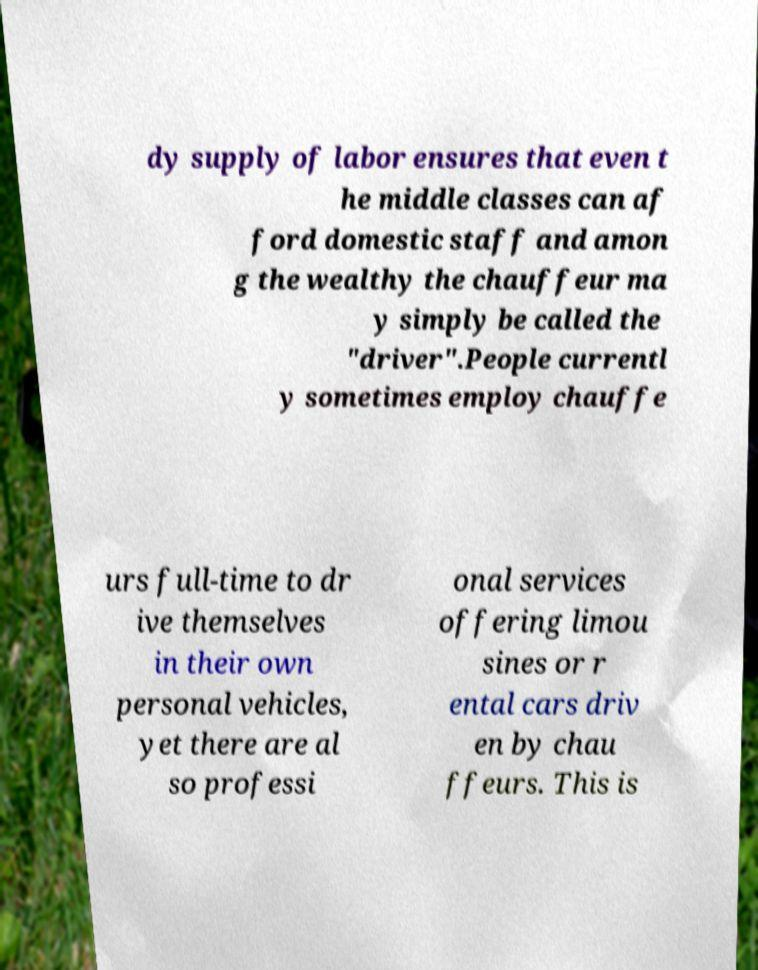Can you read and provide the text displayed in the image?This photo seems to have some interesting text. Can you extract and type it out for me? dy supply of labor ensures that even t he middle classes can af ford domestic staff and amon g the wealthy the chauffeur ma y simply be called the "driver".People currentl y sometimes employ chauffe urs full-time to dr ive themselves in their own personal vehicles, yet there are al so professi onal services offering limou sines or r ental cars driv en by chau ffeurs. This is 